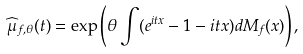<formula> <loc_0><loc_0><loc_500><loc_500>\widehat { \mu } _ { f , \theta } ( t ) = \exp \left ( \theta \int ( e ^ { i t x } - 1 - i t x ) d M _ { f } ( x ) \right ) ,</formula> 